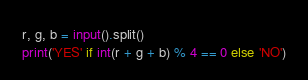Convert code to text. <code><loc_0><loc_0><loc_500><loc_500><_Python_>r, g, b = input().split()
print('YES' if int(r + g + b) % 4 == 0 else 'NO')</code> 